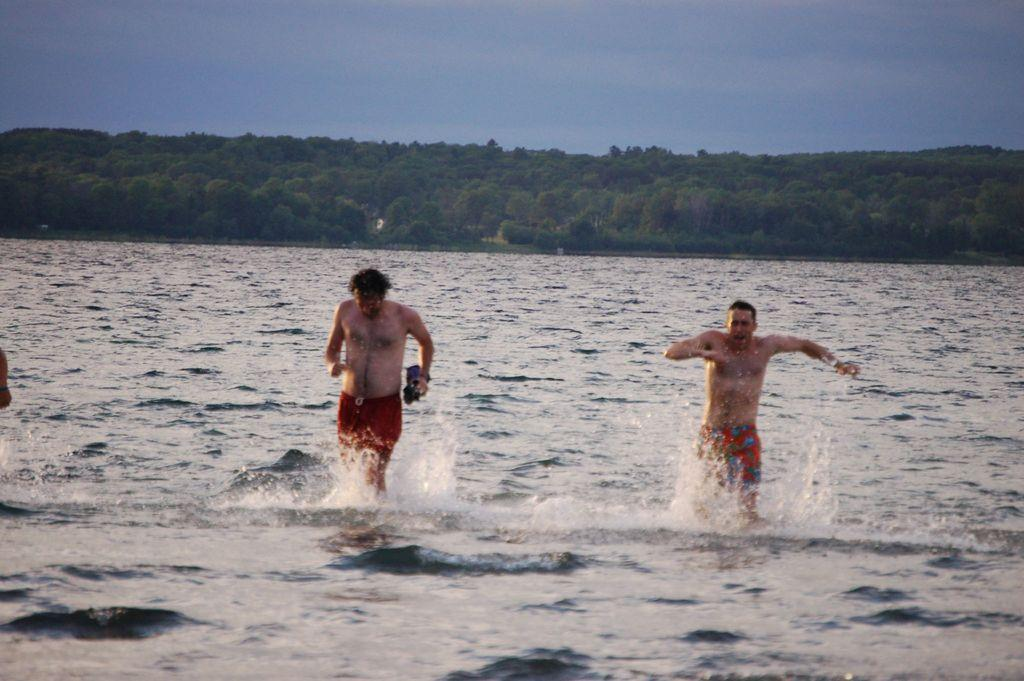How many people are in the image? There are two persons in the image. What is visible in the image besides the people? Water and trees are visible in the image. What can be seen in the background of the image? The sky is visible in the background of the image. What type of story is being told by the nose in the image? There is no nose present in the image, so it is not possible to determine if a story is being told by it. 